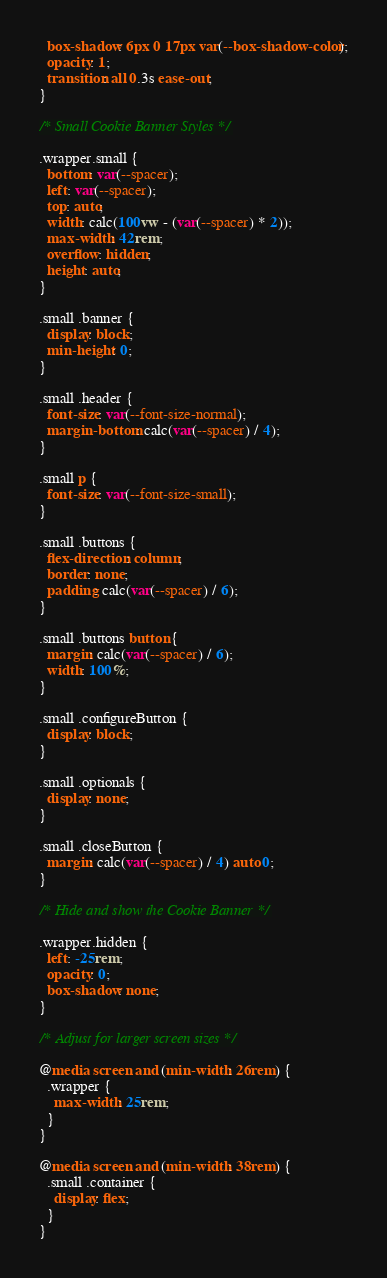<code> <loc_0><loc_0><loc_500><loc_500><_CSS_>  box-shadow: 6px 0 17px var(--box-shadow-color);
  opacity: 1;
  transition: all 0.3s ease-out;
}

/* Small Cookie Banner Styles */

.wrapper.small {
  bottom: var(--spacer);
  left: var(--spacer);
  top: auto;
  width: calc(100vw - (var(--spacer) * 2));
  max-width: 42rem;
  overflow: hidden;
  height: auto;
}

.small .banner {
  display: block;
  min-height: 0;
}

.small .header {
  font-size: var(--font-size-normal);
  margin-bottom: calc(var(--spacer) / 4);
}

.small p {
  font-size: var(--font-size-small);
}

.small .buttons {
  flex-direction: column;
  border: none;
  padding: calc(var(--spacer) / 6);
}

.small .buttons button {
  margin: calc(var(--spacer) / 6);
  width: 100%;
}

.small .configureButton {
  display: block;
}

.small .optionals {
  display: none;
}

.small .closeButton {
  margin: calc(var(--spacer) / 4) auto 0;
}

/* Hide and show the Cookie Banner */

.wrapper.hidden {
  left: -25rem;
  opacity: 0;
  box-shadow: none;
}

/* Adjust for larger screen sizes */

@media screen and (min-width: 26rem) {
  .wrapper {
    max-width: 25rem;
  }
}

@media screen and (min-width: 38rem) {
  .small .container {
    display: flex;
  }
}
</code> 